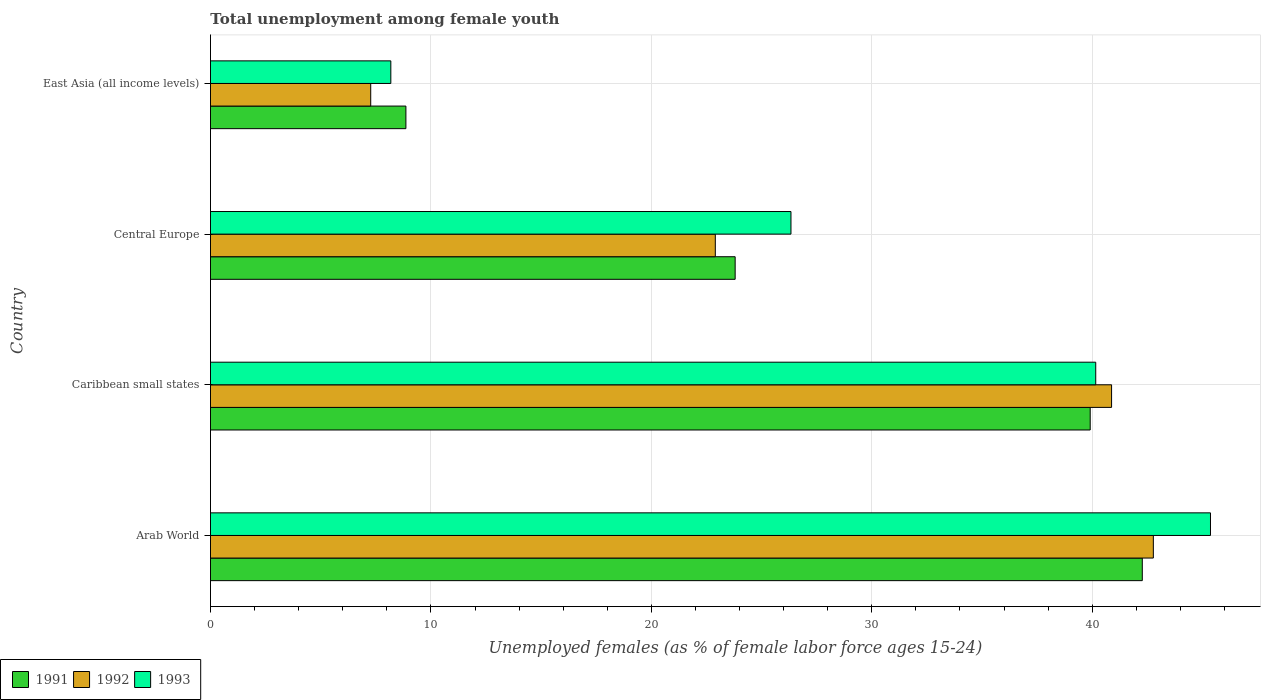Are the number of bars on each tick of the Y-axis equal?
Offer a terse response. Yes. What is the label of the 1st group of bars from the top?
Your answer should be compact. East Asia (all income levels). What is the percentage of unemployed females in in 1992 in East Asia (all income levels)?
Your answer should be compact. 7.27. Across all countries, what is the maximum percentage of unemployed females in in 1993?
Offer a terse response. 45.37. Across all countries, what is the minimum percentage of unemployed females in in 1992?
Your answer should be compact. 7.27. In which country was the percentage of unemployed females in in 1991 maximum?
Offer a very short reply. Arab World. In which country was the percentage of unemployed females in in 1991 minimum?
Your response must be concise. East Asia (all income levels). What is the total percentage of unemployed females in in 1991 in the graph?
Provide a succinct answer. 114.85. What is the difference between the percentage of unemployed females in in 1993 in Arab World and that in Caribbean small states?
Offer a very short reply. 5.21. What is the difference between the percentage of unemployed females in in 1991 in Caribbean small states and the percentage of unemployed females in in 1993 in Central Europe?
Keep it short and to the point. 13.57. What is the average percentage of unemployed females in in 1992 per country?
Provide a short and direct response. 28.46. What is the difference between the percentage of unemployed females in in 1991 and percentage of unemployed females in in 1993 in Arab World?
Offer a very short reply. -3.09. In how many countries, is the percentage of unemployed females in in 1992 greater than 6 %?
Your answer should be very brief. 4. What is the ratio of the percentage of unemployed females in in 1991 in Caribbean small states to that in East Asia (all income levels)?
Provide a succinct answer. 4.5. Is the percentage of unemployed females in in 1991 in Arab World less than that in Caribbean small states?
Your response must be concise. No. What is the difference between the highest and the second highest percentage of unemployed females in in 1991?
Provide a short and direct response. 2.36. What is the difference between the highest and the lowest percentage of unemployed females in in 1991?
Ensure brevity in your answer.  33.41. In how many countries, is the percentage of unemployed females in in 1991 greater than the average percentage of unemployed females in in 1991 taken over all countries?
Your answer should be compact. 2. Is the sum of the percentage of unemployed females in in 1991 in Caribbean small states and East Asia (all income levels) greater than the maximum percentage of unemployed females in in 1993 across all countries?
Give a very brief answer. Yes. Is it the case that in every country, the sum of the percentage of unemployed females in in 1993 and percentage of unemployed females in in 1992 is greater than the percentage of unemployed females in in 1991?
Your response must be concise. Yes. Are all the bars in the graph horizontal?
Keep it short and to the point. Yes. Are the values on the major ticks of X-axis written in scientific E-notation?
Your answer should be very brief. No. Does the graph contain any zero values?
Provide a succinct answer. No. Where does the legend appear in the graph?
Your answer should be compact. Bottom left. How many legend labels are there?
Your response must be concise. 3. What is the title of the graph?
Your answer should be very brief. Total unemployment among female youth. Does "2015" appear as one of the legend labels in the graph?
Offer a terse response. No. What is the label or title of the X-axis?
Ensure brevity in your answer.  Unemployed females (as % of female labor force ages 15-24). What is the Unemployed females (as % of female labor force ages 15-24) in 1991 in Arab World?
Your answer should be compact. 42.27. What is the Unemployed females (as % of female labor force ages 15-24) of 1992 in Arab World?
Ensure brevity in your answer.  42.77. What is the Unemployed females (as % of female labor force ages 15-24) in 1993 in Arab World?
Make the answer very short. 45.37. What is the Unemployed females (as % of female labor force ages 15-24) of 1991 in Caribbean small states?
Your response must be concise. 39.91. What is the Unemployed females (as % of female labor force ages 15-24) in 1992 in Caribbean small states?
Your answer should be compact. 40.88. What is the Unemployed females (as % of female labor force ages 15-24) of 1993 in Caribbean small states?
Provide a succinct answer. 40.16. What is the Unemployed females (as % of female labor force ages 15-24) in 1991 in Central Europe?
Provide a short and direct response. 23.8. What is the Unemployed females (as % of female labor force ages 15-24) of 1992 in Central Europe?
Your answer should be very brief. 22.9. What is the Unemployed females (as % of female labor force ages 15-24) of 1993 in Central Europe?
Provide a short and direct response. 26.33. What is the Unemployed females (as % of female labor force ages 15-24) of 1991 in East Asia (all income levels)?
Your answer should be compact. 8.87. What is the Unemployed females (as % of female labor force ages 15-24) of 1992 in East Asia (all income levels)?
Your answer should be compact. 7.27. What is the Unemployed females (as % of female labor force ages 15-24) of 1993 in East Asia (all income levels)?
Give a very brief answer. 8.18. Across all countries, what is the maximum Unemployed females (as % of female labor force ages 15-24) of 1991?
Ensure brevity in your answer.  42.27. Across all countries, what is the maximum Unemployed females (as % of female labor force ages 15-24) of 1992?
Keep it short and to the point. 42.77. Across all countries, what is the maximum Unemployed females (as % of female labor force ages 15-24) of 1993?
Provide a succinct answer. 45.37. Across all countries, what is the minimum Unemployed females (as % of female labor force ages 15-24) of 1991?
Give a very brief answer. 8.87. Across all countries, what is the minimum Unemployed females (as % of female labor force ages 15-24) in 1992?
Provide a short and direct response. 7.27. Across all countries, what is the minimum Unemployed females (as % of female labor force ages 15-24) of 1993?
Your answer should be compact. 8.18. What is the total Unemployed females (as % of female labor force ages 15-24) of 1991 in the graph?
Your answer should be very brief. 114.85. What is the total Unemployed females (as % of female labor force ages 15-24) of 1992 in the graph?
Give a very brief answer. 113.82. What is the total Unemployed females (as % of female labor force ages 15-24) of 1993 in the graph?
Keep it short and to the point. 120.04. What is the difference between the Unemployed females (as % of female labor force ages 15-24) in 1991 in Arab World and that in Caribbean small states?
Provide a short and direct response. 2.36. What is the difference between the Unemployed females (as % of female labor force ages 15-24) of 1992 in Arab World and that in Caribbean small states?
Provide a short and direct response. 1.89. What is the difference between the Unemployed females (as % of female labor force ages 15-24) of 1993 in Arab World and that in Caribbean small states?
Ensure brevity in your answer.  5.21. What is the difference between the Unemployed females (as % of female labor force ages 15-24) in 1991 in Arab World and that in Central Europe?
Make the answer very short. 18.47. What is the difference between the Unemployed females (as % of female labor force ages 15-24) in 1992 in Arab World and that in Central Europe?
Your answer should be compact. 19.87. What is the difference between the Unemployed females (as % of female labor force ages 15-24) in 1993 in Arab World and that in Central Europe?
Provide a succinct answer. 19.03. What is the difference between the Unemployed females (as % of female labor force ages 15-24) of 1991 in Arab World and that in East Asia (all income levels)?
Make the answer very short. 33.41. What is the difference between the Unemployed females (as % of female labor force ages 15-24) of 1992 in Arab World and that in East Asia (all income levels)?
Offer a terse response. 35.5. What is the difference between the Unemployed females (as % of female labor force ages 15-24) of 1993 in Arab World and that in East Asia (all income levels)?
Your answer should be compact. 37.18. What is the difference between the Unemployed females (as % of female labor force ages 15-24) in 1991 in Caribbean small states and that in Central Europe?
Provide a succinct answer. 16.11. What is the difference between the Unemployed females (as % of female labor force ages 15-24) in 1992 in Caribbean small states and that in Central Europe?
Ensure brevity in your answer.  17.98. What is the difference between the Unemployed females (as % of female labor force ages 15-24) of 1993 in Caribbean small states and that in Central Europe?
Your answer should be compact. 13.83. What is the difference between the Unemployed females (as % of female labor force ages 15-24) in 1991 in Caribbean small states and that in East Asia (all income levels)?
Offer a terse response. 31.04. What is the difference between the Unemployed females (as % of female labor force ages 15-24) of 1992 in Caribbean small states and that in East Asia (all income levels)?
Offer a very short reply. 33.61. What is the difference between the Unemployed females (as % of female labor force ages 15-24) in 1993 in Caribbean small states and that in East Asia (all income levels)?
Make the answer very short. 31.98. What is the difference between the Unemployed females (as % of female labor force ages 15-24) in 1991 in Central Europe and that in East Asia (all income levels)?
Give a very brief answer. 14.94. What is the difference between the Unemployed females (as % of female labor force ages 15-24) in 1992 in Central Europe and that in East Asia (all income levels)?
Offer a terse response. 15.63. What is the difference between the Unemployed females (as % of female labor force ages 15-24) of 1993 in Central Europe and that in East Asia (all income levels)?
Your answer should be compact. 18.15. What is the difference between the Unemployed females (as % of female labor force ages 15-24) of 1991 in Arab World and the Unemployed females (as % of female labor force ages 15-24) of 1992 in Caribbean small states?
Your response must be concise. 1.39. What is the difference between the Unemployed females (as % of female labor force ages 15-24) of 1991 in Arab World and the Unemployed females (as % of female labor force ages 15-24) of 1993 in Caribbean small states?
Provide a short and direct response. 2.11. What is the difference between the Unemployed females (as % of female labor force ages 15-24) of 1992 in Arab World and the Unemployed females (as % of female labor force ages 15-24) of 1993 in Caribbean small states?
Provide a succinct answer. 2.61. What is the difference between the Unemployed females (as % of female labor force ages 15-24) in 1991 in Arab World and the Unemployed females (as % of female labor force ages 15-24) in 1992 in Central Europe?
Offer a terse response. 19.37. What is the difference between the Unemployed females (as % of female labor force ages 15-24) in 1991 in Arab World and the Unemployed females (as % of female labor force ages 15-24) in 1993 in Central Europe?
Offer a terse response. 15.94. What is the difference between the Unemployed females (as % of female labor force ages 15-24) in 1992 in Arab World and the Unemployed females (as % of female labor force ages 15-24) in 1993 in Central Europe?
Provide a short and direct response. 16.44. What is the difference between the Unemployed females (as % of female labor force ages 15-24) of 1991 in Arab World and the Unemployed females (as % of female labor force ages 15-24) of 1992 in East Asia (all income levels)?
Keep it short and to the point. 35. What is the difference between the Unemployed females (as % of female labor force ages 15-24) in 1991 in Arab World and the Unemployed females (as % of female labor force ages 15-24) in 1993 in East Asia (all income levels)?
Provide a short and direct response. 34.09. What is the difference between the Unemployed females (as % of female labor force ages 15-24) in 1992 in Arab World and the Unemployed females (as % of female labor force ages 15-24) in 1993 in East Asia (all income levels)?
Your answer should be very brief. 34.59. What is the difference between the Unemployed females (as % of female labor force ages 15-24) of 1991 in Caribbean small states and the Unemployed females (as % of female labor force ages 15-24) of 1992 in Central Europe?
Provide a succinct answer. 17.01. What is the difference between the Unemployed females (as % of female labor force ages 15-24) in 1991 in Caribbean small states and the Unemployed females (as % of female labor force ages 15-24) in 1993 in Central Europe?
Give a very brief answer. 13.57. What is the difference between the Unemployed females (as % of female labor force ages 15-24) of 1992 in Caribbean small states and the Unemployed females (as % of female labor force ages 15-24) of 1993 in Central Europe?
Keep it short and to the point. 14.54. What is the difference between the Unemployed females (as % of female labor force ages 15-24) of 1991 in Caribbean small states and the Unemployed females (as % of female labor force ages 15-24) of 1992 in East Asia (all income levels)?
Your answer should be compact. 32.64. What is the difference between the Unemployed females (as % of female labor force ages 15-24) in 1991 in Caribbean small states and the Unemployed females (as % of female labor force ages 15-24) in 1993 in East Asia (all income levels)?
Make the answer very short. 31.73. What is the difference between the Unemployed females (as % of female labor force ages 15-24) of 1992 in Caribbean small states and the Unemployed females (as % of female labor force ages 15-24) of 1993 in East Asia (all income levels)?
Your answer should be very brief. 32.7. What is the difference between the Unemployed females (as % of female labor force ages 15-24) of 1991 in Central Europe and the Unemployed females (as % of female labor force ages 15-24) of 1992 in East Asia (all income levels)?
Give a very brief answer. 16.53. What is the difference between the Unemployed females (as % of female labor force ages 15-24) in 1991 in Central Europe and the Unemployed females (as % of female labor force ages 15-24) in 1993 in East Asia (all income levels)?
Your answer should be compact. 15.62. What is the difference between the Unemployed females (as % of female labor force ages 15-24) of 1992 in Central Europe and the Unemployed females (as % of female labor force ages 15-24) of 1993 in East Asia (all income levels)?
Your answer should be very brief. 14.72. What is the average Unemployed females (as % of female labor force ages 15-24) of 1991 per country?
Provide a short and direct response. 28.71. What is the average Unemployed females (as % of female labor force ages 15-24) of 1992 per country?
Your answer should be very brief. 28.46. What is the average Unemployed females (as % of female labor force ages 15-24) in 1993 per country?
Provide a succinct answer. 30.01. What is the difference between the Unemployed females (as % of female labor force ages 15-24) in 1991 and Unemployed females (as % of female labor force ages 15-24) in 1992 in Arab World?
Keep it short and to the point. -0.5. What is the difference between the Unemployed females (as % of female labor force ages 15-24) of 1991 and Unemployed females (as % of female labor force ages 15-24) of 1993 in Arab World?
Offer a terse response. -3.09. What is the difference between the Unemployed females (as % of female labor force ages 15-24) of 1992 and Unemployed females (as % of female labor force ages 15-24) of 1993 in Arab World?
Make the answer very short. -2.59. What is the difference between the Unemployed females (as % of female labor force ages 15-24) of 1991 and Unemployed females (as % of female labor force ages 15-24) of 1992 in Caribbean small states?
Keep it short and to the point. -0.97. What is the difference between the Unemployed females (as % of female labor force ages 15-24) in 1991 and Unemployed females (as % of female labor force ages 15-24) in 1993 in Caribbean small states?
Your answer should be compact. -0.25. What is the difference between the Unemployed females (as % of female labor force ages 15-24) in 1992 and Unemployed females (as % of female labor force ages 15-24) in 1993 in Caribbean small states?
Make the answer very short. 0.72. What is the difference between the Unemployed females (as % of female labor force ages 15-24) in 1991 and Unemployed females (as % of female labor force ages 15-24) in 1992 in Central Europe?
Your answer should be compact. 0.9. What is the difference between the Unemployed females (as % of female labor force ages 15-24) of 1991 and Unemployed females (as % of female labor force ages 15-24) of 1993 in Central Europe?
Your answer should be compact. -2.53. What is the difference between the Unemployed females (as % of female labor force ages 15-24) in 1992 and Unemployed females (as % of female labor force ages 15-24) in 1993 in Central Europe?
Your answer should be compact. -3.43. What is the difference between the Unemployed females (as % of female labor force ages 15-24) of 1991 and Unemployed females (as % of female labor force ages 15-24) of 1992 in East Asia (all income levels)?
Give a very brief answer. 1.6. What is the difference between the Unemployed females (as % of female labor force ages 15-24) in 1991 and Unemployed females (as % of female labor force ages 15-24) in 1993 in East Asia (all income levels)?
Ensure brevity in your answer.  0.68. What is the difference between the Unemployed females (as % of female labor force ages 15-24) of 1992 and Unemployed females (as % of female labor force ages 15-24) of 1993 in East Asia (all income levels)?
Keep it short and to the point. -0.91. What is the ratio of the Unemployed females (as % of female labor force ages 15-24) in 1991 in Arab World to that in Caribbean small states?
Your answer should be compact. 1.06. What is the ratio of the Unemployed females (as % of female labor force ages 15-24) of 1992 in Arab World to that in Caribbean small states?
Give a very brief answer. 1.05. What is the ratio of the Unemployed females (as % of female labor force ages 15-24) of 1993 in Arab World to that in Caribbean small states?
Keep it short and to the point. 1.13. What is the ratio of the Unemployed females (as % of female labor force ages 15-24) of 1991 in Arab World to that in Central Europe?
Offer a terse response. 1.78. What is the ratio of the Unemployed females (as % of female labor force ages 15-24) of 1992 in Arab World to that in Central Europe?
Provide a succinct answer. 1.87. What is the ratio of the Unemployed females (as % of female labor force ages 15-24) of 1993 in Arab World to that in Central Europe?
Offer a very short reply. 1.72. What is the ratio of the Unemployed females (as % of female labor force ages 15-24) in 1991 in Arab World to that in East Asia (all income levels)?
Offer a very short reply. 4.77. What is the ratio of the Unemployed females (as % of female labor force ages 15-24) in 1992 in Arab World to that in East Asia (all income levels)?
Make the answer very short. 5.88. What is the ratio of the Unemployed females (as % of female labor force ages 15-24) of 1993 in Arab World to that in East Asia (all income levels)?
Give a very brief answer. 5.54. What is the ratio of the Unemployed females (as % of female labor force ages 15-24) of 1991 in Caribbean small states to that in Central Europe?
Give a very brief answer. 1.68. What is the ratio of the Unemployed females (as % of female labor force ages 15-24) of 1992 in Caribbean small states to that in Central Europe?
Offer a very short reply. 1.78. What is the ratio of the Unemployed females (as % of female labor force ages 15-24) of 1993 in Caribbean small states to that in Central Europe?
Give a very brief answer. 1.52. What is the ratio of the Unemployed females (as % of female labor force ages 15-24) in 1991 in Caribbean small states to that in East Asia (all income levels)?
Give a very brief answer. 4.5. What is the ratio of the Unemployed females (as % of female labor force ages 15-24) of 1992 in Caribbean small states to that in East Asia (all income levels)?
Your response must be concise. 5.62. What is the ratio of the Unemployed females (as % of female labor force ages 15-24) of 1993 in Caribbean small states to that in East Asia (all income levels)?
Offer a very short reply. 4.91. What is the ratio of the Unemployed females (as % of female labor force ages 15-24) of 1991 in Central Europe to that in East Asia (all income levels)?
Give a very brief answer. 2.68. What is the ratio of the Unemployed females (as % of female labor force ages 15-24) in 1992 in Central Europe to that in East Asia (all income levels)?
Provide a succinct answer. 3.15. What is the ratio of the Unemployed females (as % of female labor force ages 15-24) in 1993 in Central Europe to that in East Asia (all income levels)?
Offer a very short reply. 3.22. What is the difference between the highest and the second highest Unemployed females (as % of female labor force ages 15-24) in 1991?
Your answer should be very brief. 2.36. What is the difference between the highest and the second highest Unemployed females (as % of female labor force ages 15-24) of 1992?
Give a very brief answer. 1.89. What is the difference between the highest and the second highest Unemployed females (as % of female labor force ages 15-24) of 1993?
Your response must be concise. 5.21. What is the difference between the highest and the lowest Unemployed females (as % of female labor force ages 15-24) of 1991?
Ensure brevity in your answer.  33.41. What is the difference between the highest and the lowest Unemployed females (as % of female labor force ages 15-24) of 1992?
Give a very brief answer. 35.5. What is the difference between the highest and the lowest Unemployed females (as % of female labor force ages 15-24) of 1993?
Make the answer very short. 37.18. 